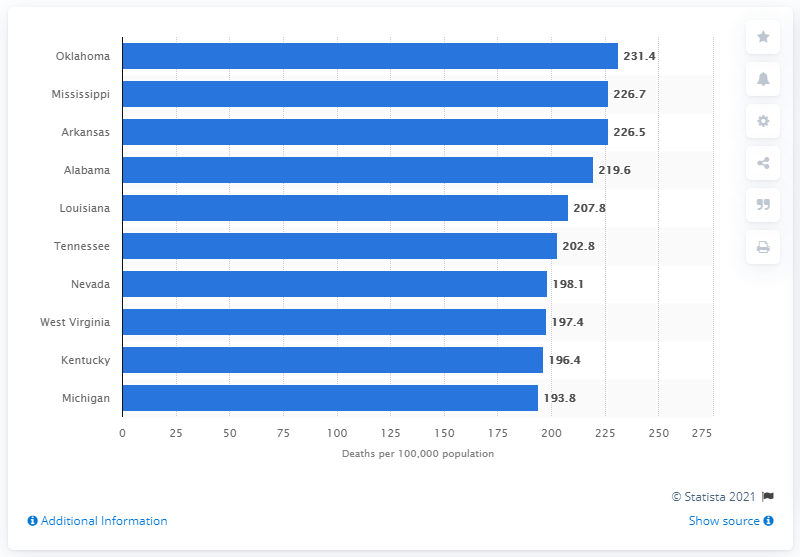Mention a couple of crucial points in this snapshot. The state of Arkansas had the third highest rate of heart disease deaths in the United States in 2019, according to data. 